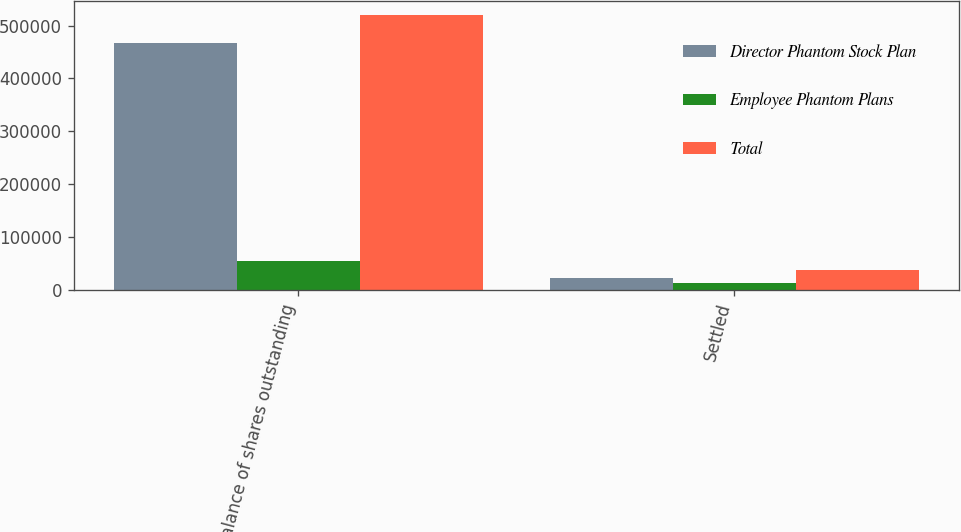Convert chart. <chart><loc_0><loc_0><loc_500><loc_500><stacked_bar_chart><ecel><fcel>Balance of shares outstanding<fcel>Settled<nl><fcel>Director Phantom Stock Plan<fcel>466387<fcel>23419<nl><fcel>Employee Phantom Plans<fcel>54071<fcel>14091<nl><fcel>Total<fcel>520458<fcel>37510<nl></chart> 